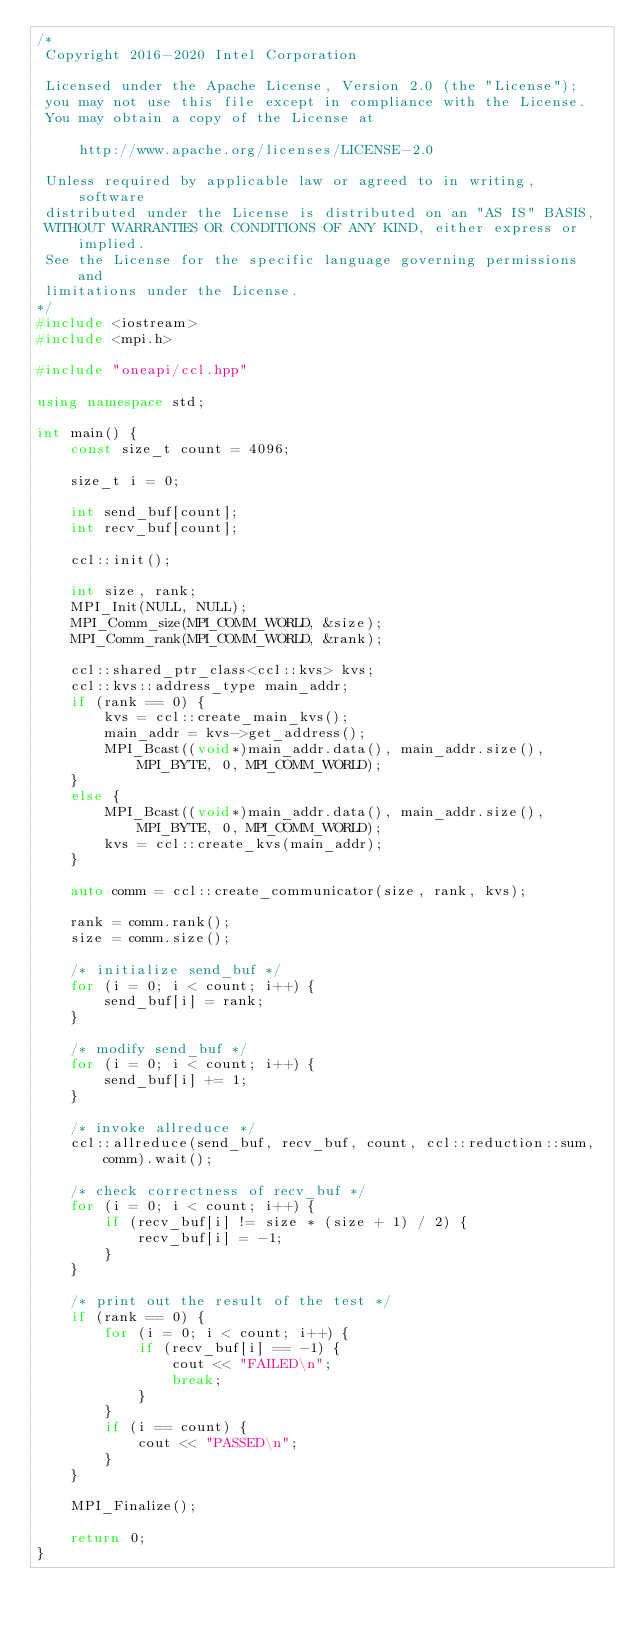<code> <loc_0><loc_0><loc_500><loc_500><_C++_>/*
 Copyright 2016-2020 Intel Corporation
 
 Licensed under the Apache License, Version 2.0 (the "License");
 you may not use this file except in compliance with the License.
 You may obtain a copy of the License at
 
     http://www.apache.org/licenses/LICENSE-2.0
 
 Unless required by applicable law or agreed to in writing, software
 distributed under the License is distributed on an "AS IS" BASIS,
 WITHOUT WARRANTIES OR CONDITIONS OF ANY KIND, either express or implied.
 See the License for the specific language governing permissions and
 limitations under the License.
*/
#include <iostream>
#include <mpi.h>

#include "oneapi/ccl.hpp"

using namespace std;

int main() {
    const size_t count = 4096;

    size_t i = 0;

    int send_buf[count];
    int recv_buf[count];

    ccl::init();

    int size, rank;
    MPI_Init(NULL, NULL);
    MPI_Comm_size(MPI_COMM_WORLD, &size);
    MPI_Comm_rank(MPI_COMM_WORLD, &rank);

    ccl::shared_ptr_class<ccl::kvs> kvs;
    ccl::kvs::address_type main_addr;
    if (rank == 0) {
        kvs = ccl::create_main_kvs();
        main_addr = kvs->get_address();
        MPI_Bcast((void*)main_addr.data(), main_addr.size(), MPI_BYTE, 0, MPI_COMM_WORLD);
    }
    else {
        MPI_Bcast((void*)main_addr.data(), main_addr.size(), MPI_BYTE, 0, MPI_COMM_WORLD);
        kvs = ccl::create_kvs(main_addr);
    }

    auto comm = ccl::create_communicator(size, rank, kvs);

    rank = comm.rank();
    size = comm.size();

    /* initialize send_buf */
    for (i = 0; i < count; i++) {
        send_buf[i] = rank;
    }

    /* modify send_buf */
    for (i = 0; i < count; i++) {
        send_buf[i] += 1;
    }

    /* invoke allreduce */
    ccl::allreduce(send_buf, recv_buf, count, ccl::reduction::sum, comm).wait();

    /* check correctness of recv_buf */
    for (i = 0; i < count; i++) {
        if (recv_buf[i] != size * (size + 1) / 2) {
            recv_buf[i] = -1;
        }
    }

    /* print out the result of the test */
    if (rank == 0) {
        for (i = 0; i < count; i++) {
            if (recv_buf[i] == -1) {
                cout << "FAILED\n";
                break;
            }
        }
        if (i == count) {
            cout << "PASSED\n";
        }
    }

    MPI_Finalize();

    return 0;
}
</code> 